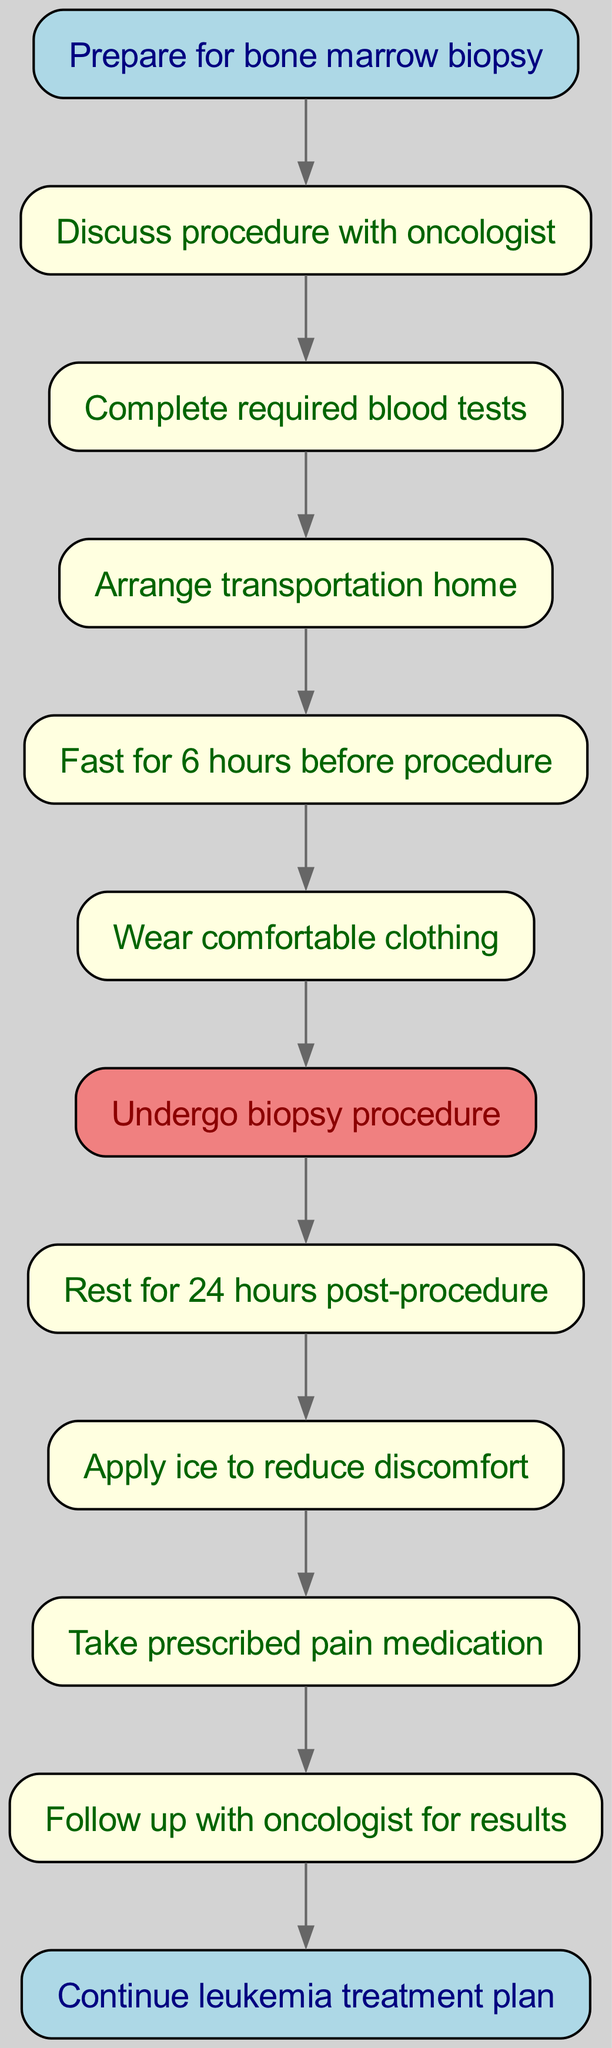What is the first step in preparing for a bone marrow biopsy? The first step is represented by the start node, which is labeled "Prepare for bone marrow biopsy." This indicates the initial action in the flow chart.
Answer: Prepare for bone marrow biopsy How many total steps are listed in the diagram? The diagram lists ten steps in total, from the initial preparation to the final follow-up. Each step is represented by a node between the start and end nodes, including the end node itself.
Answer: Ten What must be completed before arranging transportation home? According to the flow chart, the step that must be completed before arranging transportation is "Complete required blood tests." This indicates the sequential nature of the steps.
Answer: Complete required blood tests What is done to manage discomfort after the biopsy procedure? After the biopsy procedure, ice is applied to manage discomfort, as indicated in the node that connects to "Apply ice to reduce discomfort." This step directly addresses post-procedure care.
Answer: Apply ice What follows immediately after discussing the procedure with the oncologist? The next step that follows discussing the procedure with the oncologist is "Complete required blood tests." This shows the order of steps and ensures necessary preparations are made before the biopsy.
Answer: Complete required blood tests What is the purpose of fasting for six hours before the procedure? Fasting for six hours before the procedure is necessary to ensure that the patient’s body is ready for the biopsy, as indicated in the flow chart's instructions for pre-procedure care.
Answer: Ensure readiness Which step directly follows the biopsy procedure? The step that directly follows the biopsy procedure, as stated in the flow chart, is "Rest for 24 hours post-procedure." This is essential for recovery after the biopsy.
Answer: Rest for 24 hours post-procedure What is the last step indicated in the flow chart? The last step shown in the flow chart is "Continue leukemia treatment plan," which follows the final follow-up with the oncologist for results. This emphasizes the ongoing nature of the treatment process.
Answer: Continue leukemia treatment plan 